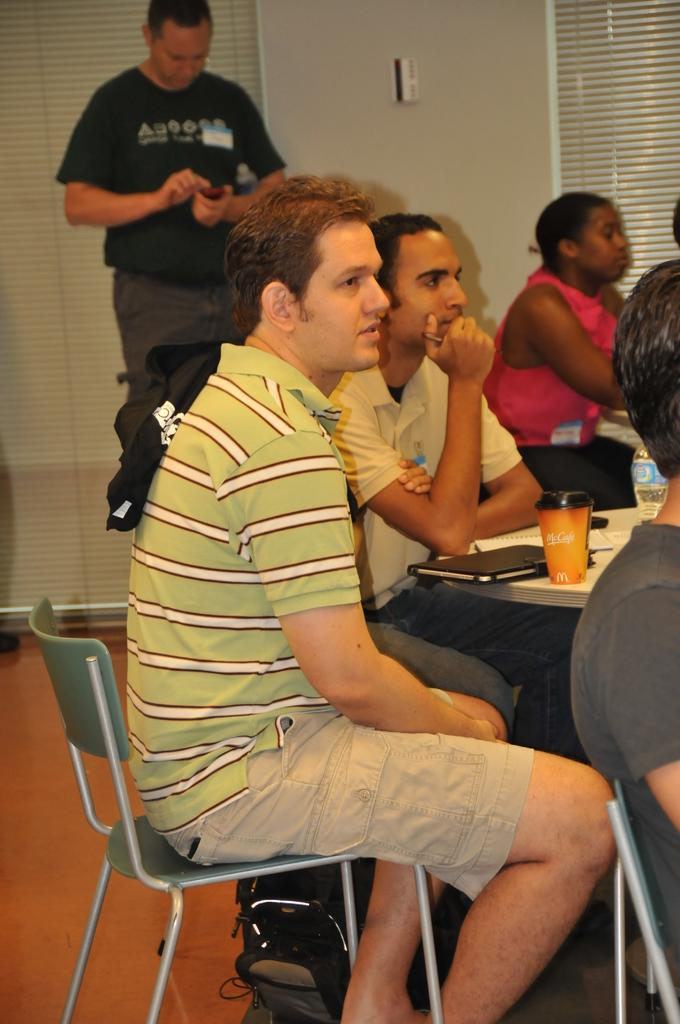What are the people in the image doing? There are persons sitting on chairs in the image. What objects are on the table in the image? There are papers, a glass, and a bottle on the table in the image. Can you describe the person in the background of the image? There is a man standing in the background of the image. What is visible in the background of the image? There is a wall visible in the background of the image. What type of instrument is the person playing in the image? There is no person playing an instrument in the image. What is the weight of the lace on the table in the image? There is no lace present in the image. 